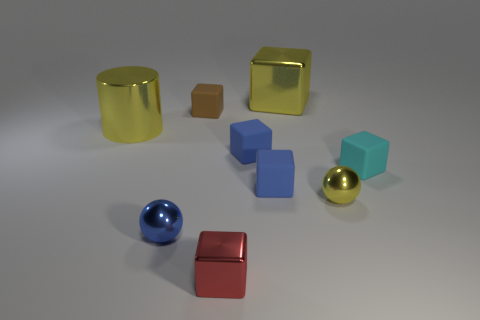Subtract 2 blocks. How many blocks are left? 4 Subtract all blue cubes. How many cubes are left? 4 Subtract all big cubes. How many cubes are left? 5 Subtract all cyan cubes. Subtract all red cylinders. How many cubes are left? 5 Add 1 matte objects. How many objects exist? 10 Subtract all blocks. How many objects are left? 3 Subtract all blue rubber things. Subtract all yellow metallic blocks. How many objects are left? 6 Add 8 tiny red metal things. How many tiny red metal things are left? 9 Add 4 rubber things. How many rubber things exist? 8 Subtract 0 brown balls. How many objects are left? 9 